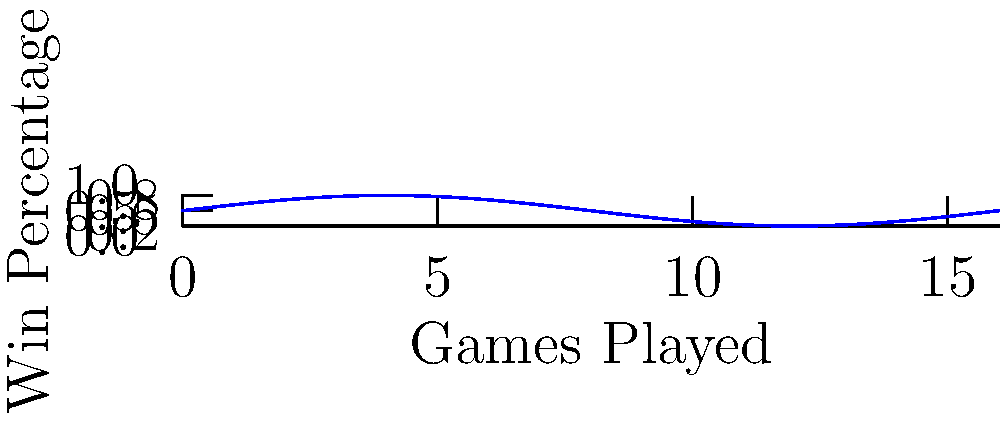The graph above represents a team's win percentage over a 16-game season. The win percentage ($y$) as a function of games played ($x$) is given by the equation:

$$ y = 0.5 + 0.3\sin(\frac{\pi x}{8}) $$

Calculate the area under this curve from $x=0$ to $x=16$. This value represents the cumulative win percentage for the season. What is the team's final win-loss record based on this result? To solve this problem, we need to follow these steps:

1) The area under the curve is given by the definite integral:

   $$ A = \int_0^{16} (0.5 + 0.3\sin(\frac{\pi x}{8})) dx $$

2) Let's break this into two parts:
   
   $$ A = \int_0^{16} 0.5 dx + \int_0^{16} 0.3\sin(\frac{\pi x}{8}) dx $$

3) The first part is straightforward:
   
   $$ \int_0^{16} 0.5 dx = 0.5x \bigg|_0^{16} = 8 $$

4) For the second part, we can use the substitution $u = \frac{\pi x}{8}$:
   
   $$ \int_0^{16} 0.3\sin(\frac{\pi x}{8}) dx = \frac{2.4}{\pi} \int_0^{2\pi} \sin(u) du $$

5) We know that $\int_0^{2\pi} \sin(u) du = 0$, so this part equals zero.

6) Therefore, the total area is just 8.

7) This means that over 16 games, the team won the equivalent of 8 games.

8) The team's record would be 8 wins and 8 losses (8-8).
Answer: 8-8 